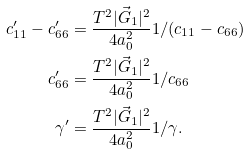Convert formula to latex. <formula><loc_0><loc_0><loc_500><loc_500>c ^ { \prime } _ { 1 1 } - c ^ { \prime } _ { 6 6 } & = \frac { T ^ { 2 } | \vec { G } _ { 1 } | ^ { 2 } } { 4 a _ { 0 } ^ { 2 } } 1 / ( c _ { 1 1 } - c _ { 6 6 } ) \\ c ^ { \prime } _ { 6 6 } & = \frac { T ^ { 2 } | \vec { G } _ { 1 } | ^ { 2 } } { 4 a _ { 0 } ^ { 2 } } 1 / c _ { 6 6 } \\ \gamma ^ { \prime } & = \frac { T ^ { 2 } | \vec { G } _ { 1 } | ^ { 2 } } { 4 a _ { 0 } ^ { 2 } } 1 / \gamma .</formula> 